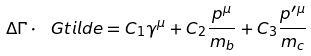<formula> <loc_0><loc_0><loc_500><loc_500>\Delta \Gamma \cdot \ G t i l d e = C _ { 1 } \gamma ^ { \mu } + C _ { 2 } \frac { p ^ { \mu } } { m _ { b } } + C _ { 3 } \frac { p ^ { \prime \mu } } { m _ { c } }</formula> 